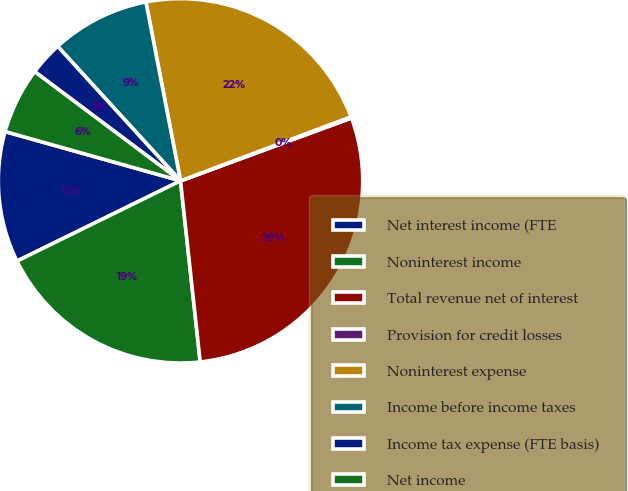Convert chart. <chart><loc_0><loc_0><loc_500><loc_500><pie_chart><fcel>Net interest income (FTE<fcel>Noninterest income<fcel>Total revenue net of interest<fcel>Provision for credit losses<fcel>Noninterest expense<fcel>Income before income taxes<fcel>Income tax expense (FTE basis)<fcel>Net income<nl><fcel>11.62%<fcel>19.46%<fcel>28.88%<fcel>0.11%<fcel>22.33%<fcel>8.74%<fcel>2.99%<fcel>5.87%<nl></chart> 